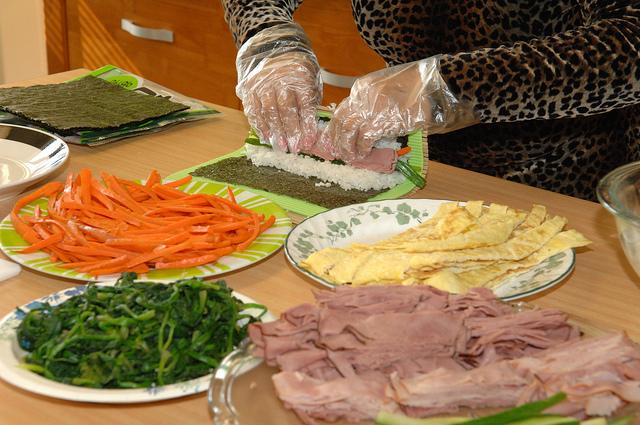What dish is the person assembling these food items to mimic? Please explain your reasoning. sushi. They are wrapping the food inside of seaweed paper and rice. 